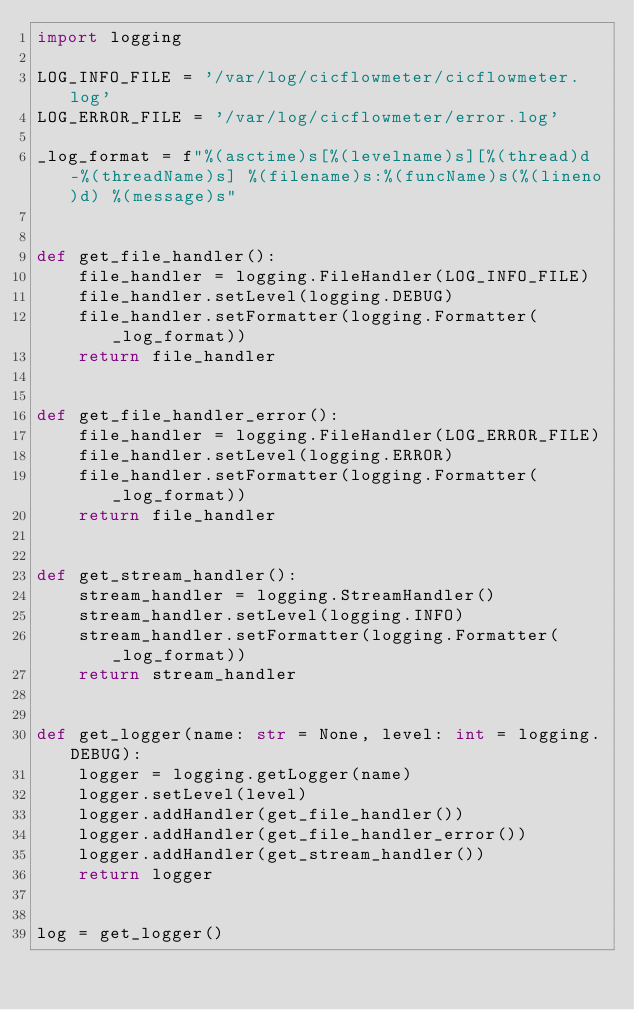<code> <loc_0><loc_0><loc_500><loc_500><_Python_>import logging

LOG_INFO_FILE = '/var/log/cicflowmeter/cicflowmeter.log'
LOG_ERROR_FILE = '/var/log/cicflowmeter/error.log'

_log_format = f"%(asctime)s[%(levelname)s][%(thread)d-%(threadName)s] %(filename)s:%(funcName)s(%(lineno)d) %(message)s"


def get_file_handler():
    file_handler = logging.FileHandler(LOG_INFO_FILE)
    file_handler.setLevel(logging.DEBUG)
    file_handler.setFormatter(logging.Formatter(_log_format))
    return file_handler


def get_file_handler_error():
    file_handler = logging.FileHandler(LOG_ERROR_FILE)
    file_handler.setLevel(logging.ERROR)
    file_handler.setFormatter(logging.Formatter(_log_format))
    return file_handler


def get_stream_handler():
    stream_handler = logging.StreamHandler()
    stream_handler.setLevel(logging.INFO)
    stream_handler.setFormatter(logging.Formatter(_log_format))
    return stream_handler


def get_logger(name: str = None, level: int = logging.DEBUG):
    logger = logging.getLogger(name)
    logger.setLevel(level)
    logger.addHandler(get_file_handler())
    logger.addHandler(get_file_handler_error())
    logger.addHandler(get_stream_handler())
    return logger


log = get_logger()
</code> 